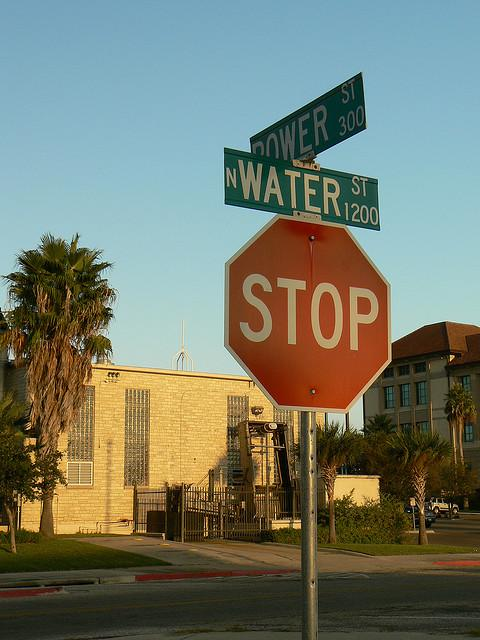What is next to the building? tree 